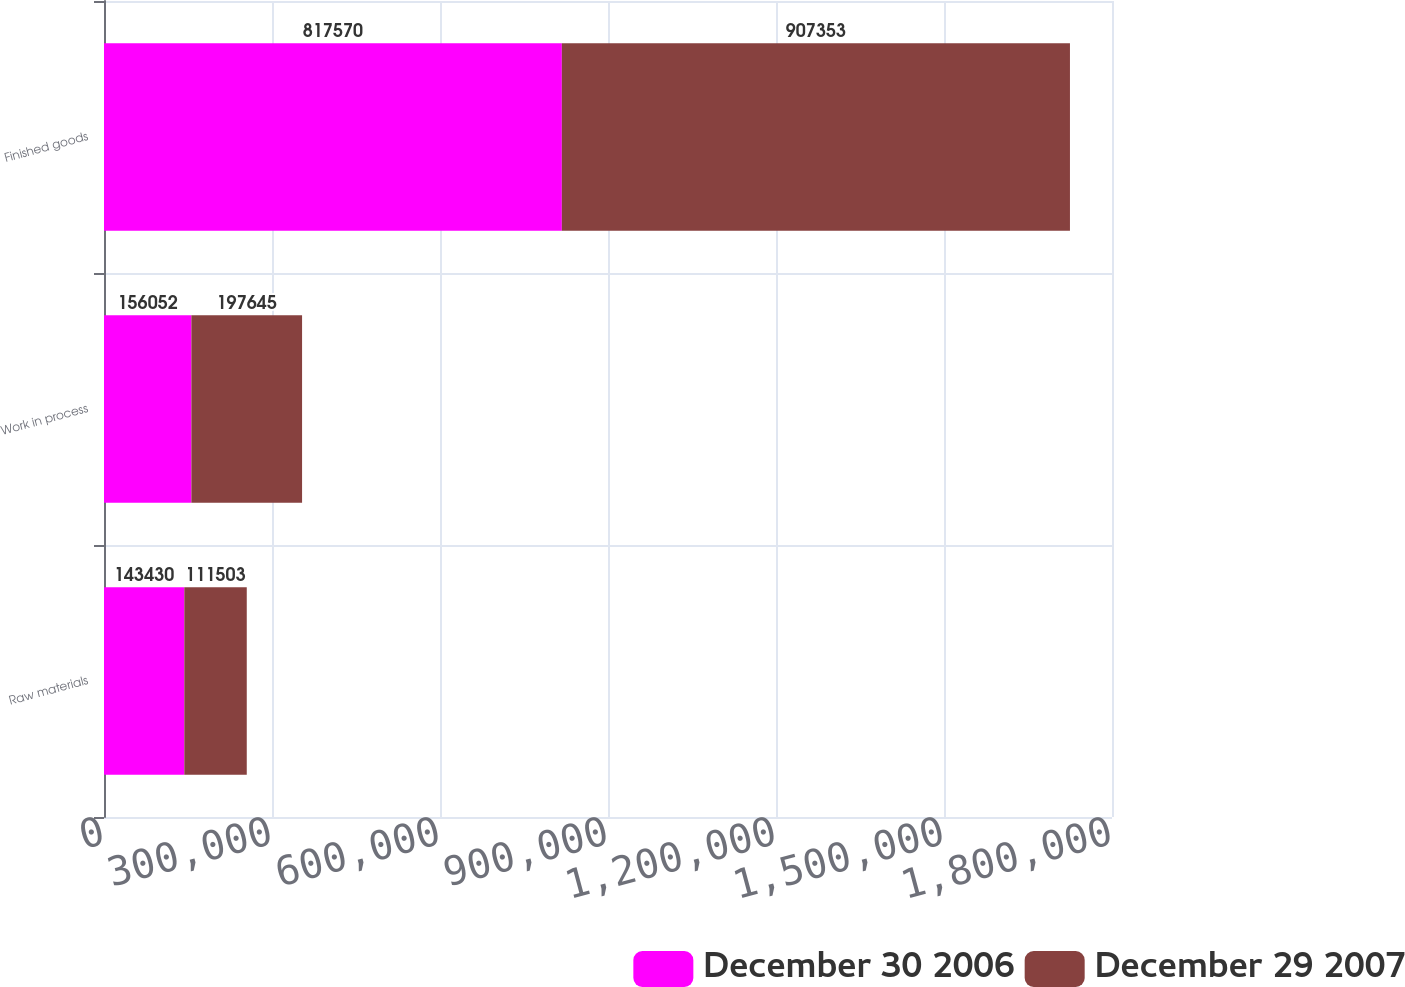Convert chart. <chart><loc_0><loc_0><loc_500><loc_500><stacked_bar_chart><ecel><fcel>Raw materials<fcel>Work in process<fcel>Finished goods<nl><fcel>December 30 2006<fcel>143430<fcel>156052<fcel>817570<nl><fcel>December 29 2007<fcel>111503<fcel>197645<fcel>907353<nl></chart> 